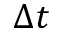Convert formula to latex. <formula><loc_0><loc_0><loc_500><loc_500>\Delta t</formula> 